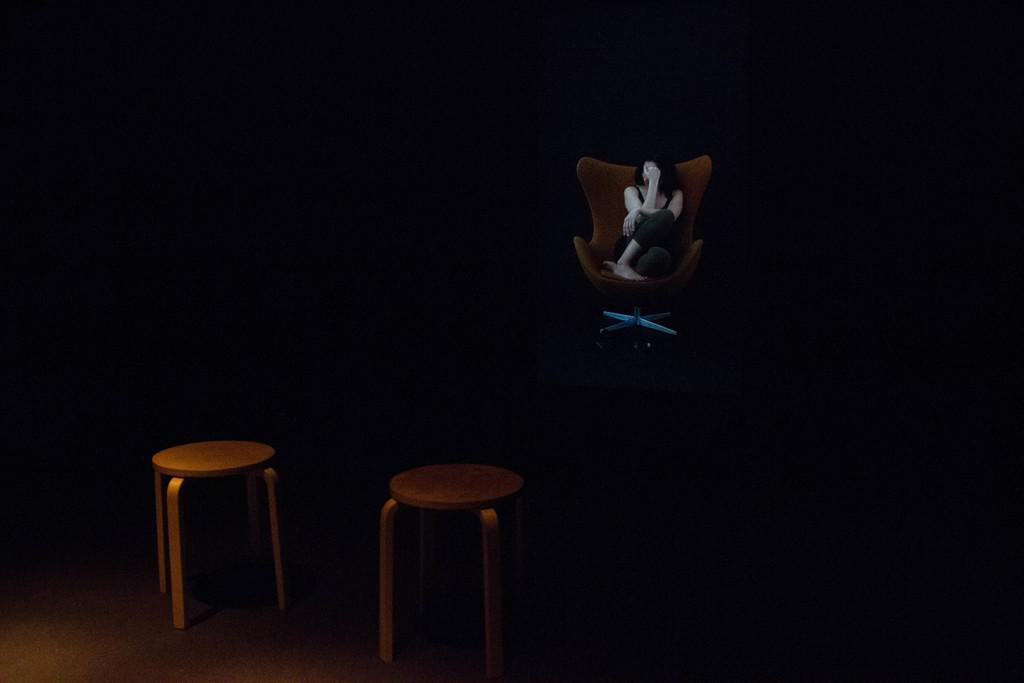What is the woman in the image doing? The woman is sitting on a chair in the image. How many tables are visible in the image? There are two tables in the image, one in the middle and one on the left side. What can be seen in the background of the image? The background of the image appears to be black. What type of linen is draped over the woman's chair in the image? There is no linen draped over the woman's chair in the image. Can you see a rat in the image? There is no rat present in the image. 